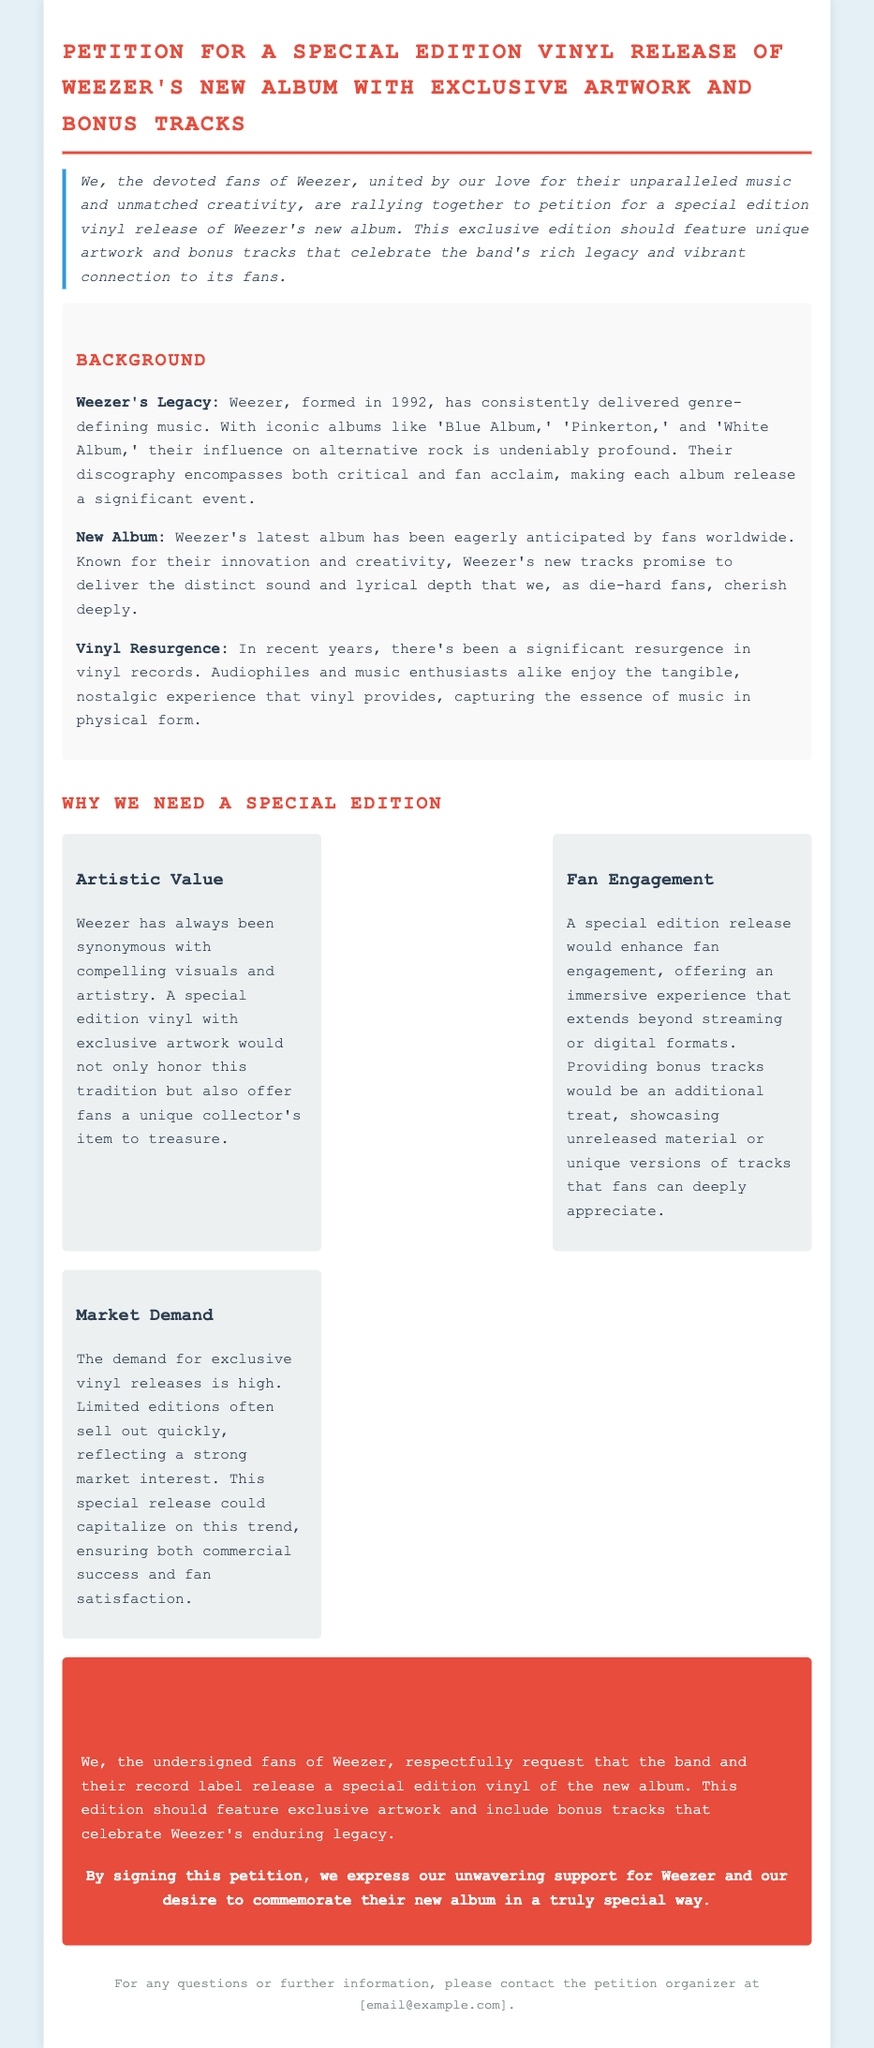What is the title of the petition? The title is stated at the top of the document as "Petition for a Special Edition Vinyl Release of Weezer's New Album with Exclusive Artwork and Bonus Tracks."
Answer: Petition for a Special Edition Vinyl Release of Weezer's New Album with Exclusive Artwork and Bonus Tracks What is the year Weezer was formed? The document mentions that Weezer was formed in 1992.
Answer: 1992 What is the signature color used in headings? The headings are styled using a specific color referenced in the document, which is "#e74c3c."
Answer: #e74c3c What type of experience would a special edition release enhance? The document states it would enhance "fan engagement."
Answer: fan engagement What does the petition request regarding the new album? The petition requests the release of a special edition vinyl of the new album with specific features mentioned in the document.
Answer: exclusive artwork and bonus tracks What recent trend does the petition mention regarding vinyl records? The petition notes a "significant resurgence in vinyl records."
Answer: resurgence in vinyl records What is the email contact for further information? The document provides a placeholder for the contact email, stated as "[email@example.com]."
Answer: [email@example.com] How are the arguments for the special edition vinyl presented in the document? The arguments are laid out in a flexible format and categorized with titles, specifically emphasizing artistic value, fan engagement, and market demand.
Answer: categorically with titles 